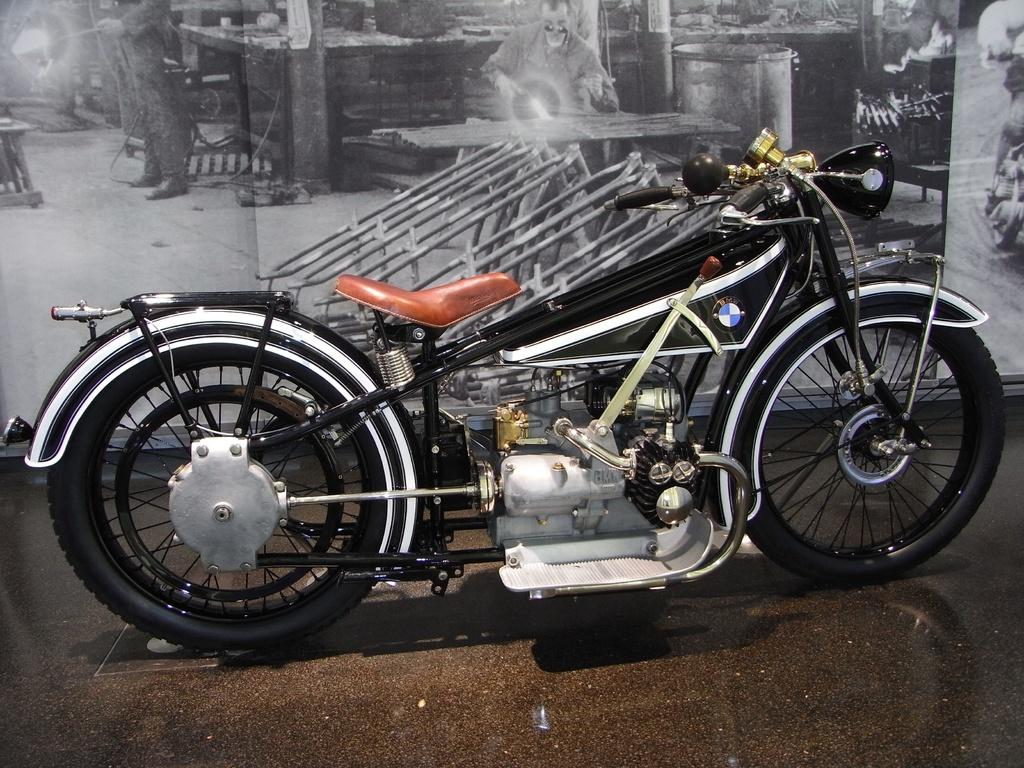What is placed on the floor in the image? There is a vehicle on the floor in the image. What can be seen in the background of the image? There is a poster with some depictions in the background of the image. What type of tub can be seen in the image? There is no tub present in the image. What is the vehicle in the image using to consume eggnog? The image does not show the vehicle consuming eggnog, nor is there any eggnog present. 